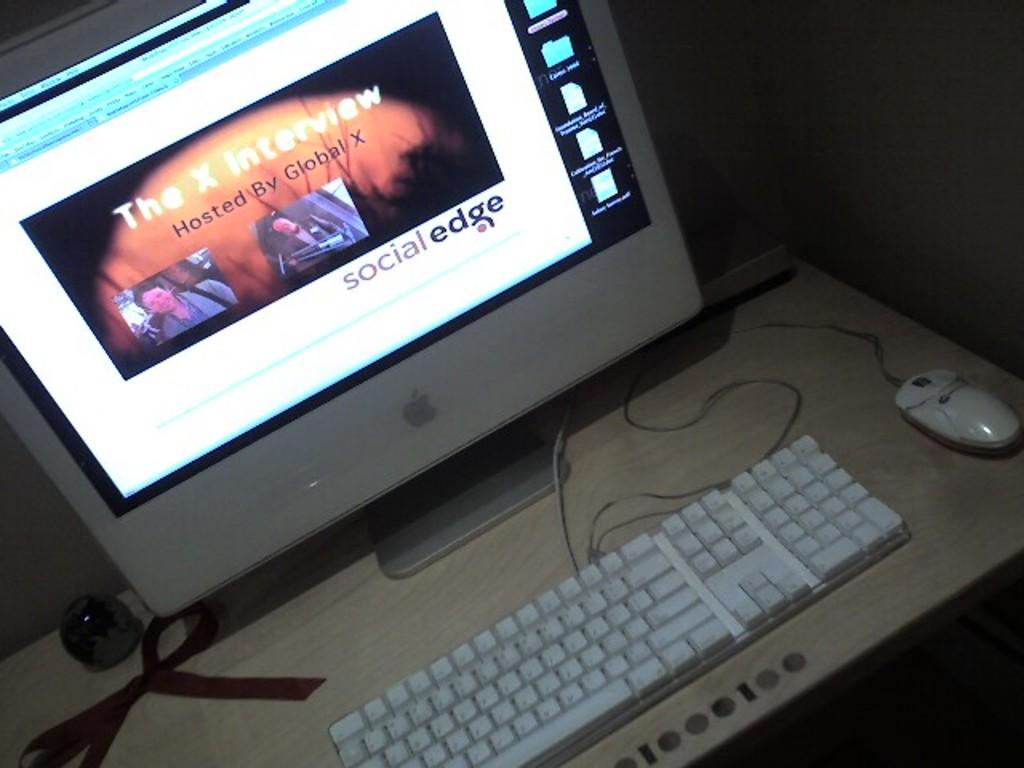Who is the interview hosted by?
Offer a very short reply. Global x. Is this an earlier version of mac book?
Offer a very short reply. Answering does not require reading text in the image. 